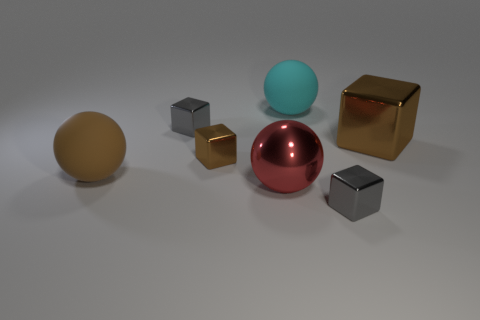There is a gray cube that is in front of the large matte ball in front of the small brown shiny object; how many brown rubber objects are behind it?
Keep it short and to the point. 1. What number of purple objects are large balls or tiny things?
Ensure brevity in your answer.  0. There is a cyan object; is its size the same as the brown cube on the right side of the red metallic ball?
Your response must be concise. Yes. There is a large thing that is the same shape as the tiny brown thing; what is it made of?
Provide a short and direct response. Metal. What number of other objects are there of the same size as the cyan rubber thing?
Your answer should be compact. 3. There is a gray object on the left side of the matte thing behind the tiny gray shiny cube that is to the left of the cyan rubber sphere; what is its shape?
Offer a very short reply. Cube. There is a thing that is both in front of the cyan ball and behind the large metal cube; what shape is it?
Provide a short and direct response. Cube. What number of things are small brown balls or large rubber balls on the left side of the cyan rubber sphere?
Offer a very short reply. 1. Does the big brown cube have the same material as the cyan sphere?
Provide a succinct answer. No. What number of other things are there of the same shape as the cyan object?
Offer a very short reply. 2. 